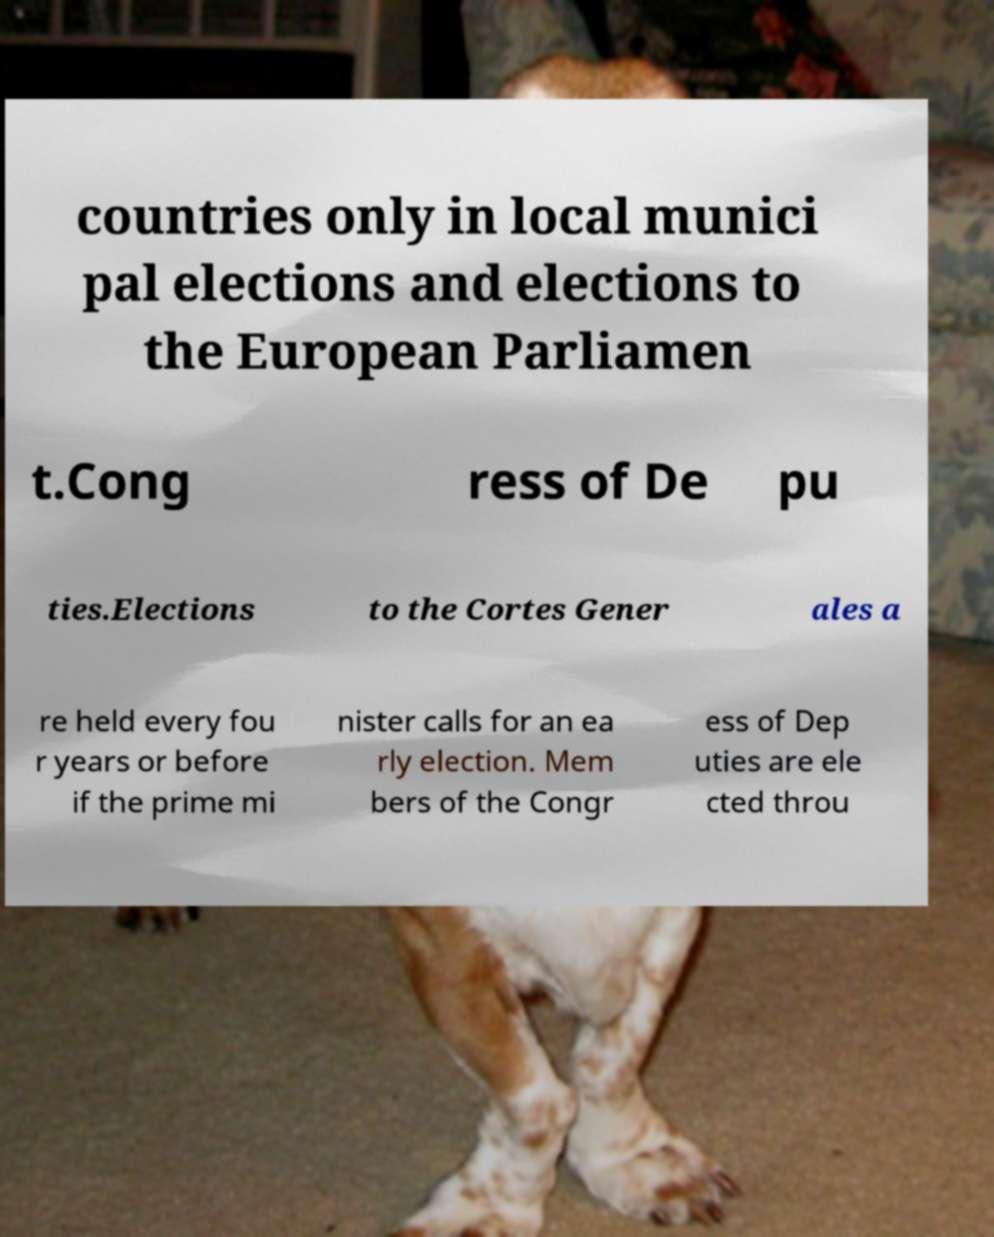Please identify and transcribe the text found in this image. countries only in local munici pal elections and elections to the European Parliamen t.Cong ress of De pu ties.Elections to the Cortes Gener ales a re held every fou r years or before if the prime mi nister calls for an ea rly election. Mem bers of the Congr ess of Dep uties are ele cted throu 